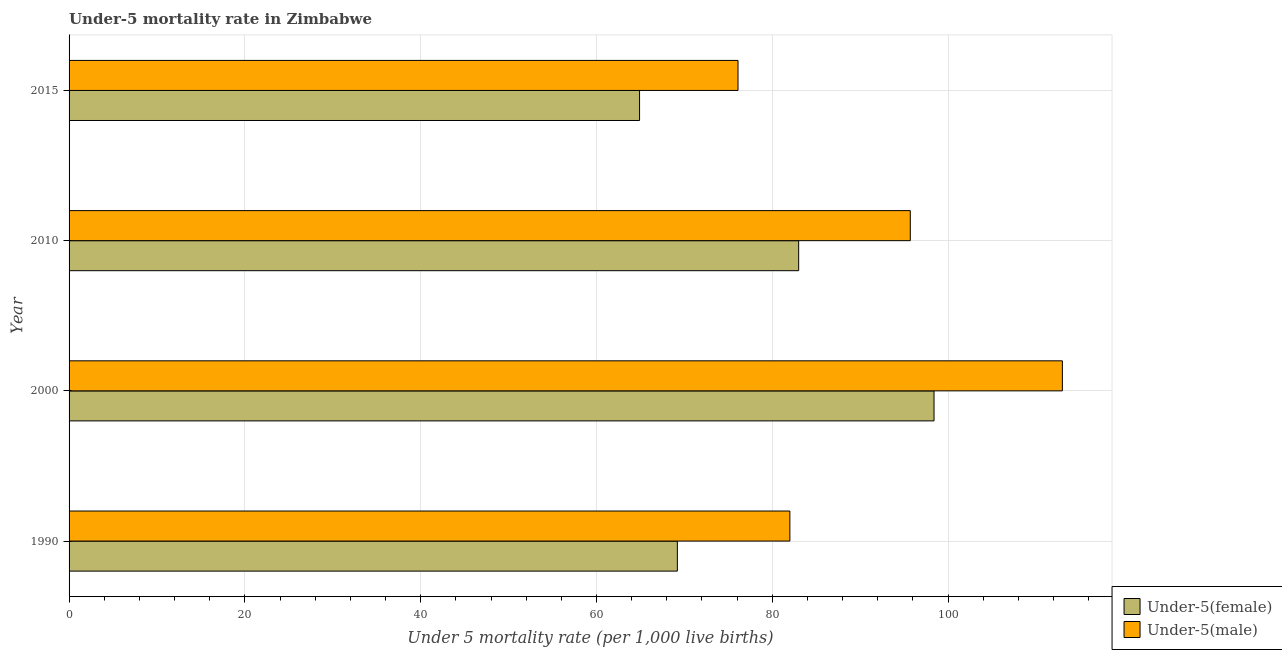Are the number of bars on each tick of the Y-axis equal?
Your answer should be compact. Yes. How many bars are there on the 1st tick from the bottom?
Your answer should be compact. 2. What is the label of the 3rd group of bars from the top?
Your answer should be compact. 2000. In how many cases, is the number of bars for a given year not equal to the number of legend labels?
Offer a terse response. 0. What is the under-5 female mortality rate in 2015?
Keep it short and to the point. 64.9. Across all years, what is the maximum under-5 male mortality rate?
Your answer should be compact. 113. Across all years, what is the minimum under-5 female mortality rate?
Your response must be concise. 64.9. In which year was the under-5 female mortality rate minimum?
Keep it short and to the point. 2015. What is the total under-5 male mortality rate in the graph?
Give a very brief answer. 366.8. What is the difference between the under-5 male mortality rate in 1990 and that in 2010?
Provide a short and direct response. -13.7. What is the difference between the under-5 male mortality rate in 2010 and the under-5 female mortality rate in 2000?
Your answer should be very brief. -2.7. What is the average under-5 female mortality rate per year?
Provide a short and direct response. 78.88. In the year 2015, what is the difference between the under-5 male mortality rate and under-5 female mortality rate?
Your response must be concise. 11.2. What is the ratio of the under-5 female mortality rate in 1990 to that in 2015?
Your answer should be compact. 1.07. What is the difference between the highest and the second highest under-5 male mortality rate?
Make the answer very short. 17.3. What is the difference between the highest and the lowest under-5 female mortality rate?
Your response must be concise. 33.5. In how many years, is the under-5 female mortality rate greater than the average under-5 female mortality rate taken over all years?
Offer a terse response. 2. What does the 2nd bar from the top in 2000 represents?
Ensure brevity in your answer.  Under-5(female). What does the 1st bar from the bottom in 2010 represents?
Offer a very short reply. Under-5(female). How many bars are there?
Your response must be concise. 8. Are the values on the major ticks of X-axis written in scientific E-notation?
Offer a very short reply. No. Does the graph contain any zero values?
Your response must be concise. No. What is the title of the graph?
Your answer should be compact. Under-5 mortality rate in Zimbabwe. Does "Working capital" appear as one of the legend labels in the graph?
Ensure brevity in your answer.  No. What is the label or title of the X-axis?
Your response must be concise. Under 5 mortality rate (per 1,0 live births). What is the Under 5 mortality rate (per 1,000 live births) of Under-5(female) in 1990?
Make the answer very short. 69.2. What is the Under 5 mortality rate (per 1,000 live births) of Under-5(female) in 2000?
Your response must be concise. 98.4. What is the Under 5 mortality rate (per 1,000 live births) in Under-5(male) in 2000?
Provide a short and direct response. 113. What is the Under 5 mortality rate (per 1,000 live births) of Under-5(female) in 2010?
Ensure brevity in your answer.  83. What is the Under 5 mortality rate (per 1,000 live births) in Under-5(male) in 2010?
Make the answer very short. 95.7. What is the Under 5 mortality rate (per 1,000 live births) in Under-5(female) in 2015?
Ensure brevity in your answer.  64.9. What is the Under 5 mortality rate (per 1,000 live births) in Under-5(male) in 2015?
Give a very brief answer. 76.1. Across all years, what is the maximum Under 5 mortality rate (per 1,000 live births) of Under-5(female)?
Your answer should be compact. 98.4. Across all years, what is the maximum Under 5 mortality rate (per 1,000 live births) of Under-5(male)?
Offer a very short reply. 113. Across all years, what is the minimum Under 5 mortality rate (per 1,000 live births) in Under-5(female)?
Your answer should be very brief. 64.9. Across all years, what is the minimum Under 5 mortality rate (per 1,000 live births) in Under-5(male)?
Your answer should be very brief. 76.1. What is the total Under 5 mortality rate (per 1,000 live births) of Under-5(female) in the graph?
Offer a very short reply. 315.5. What is the total Under 5 mortality rate (per 1,000 live births) in Under-5(male) in the graph?
Your answer should be very brief. 366.8. What is the difference between the Under 5 mortality rate (per 1,000 live births) of Under-5(female) in 1990 and that in 2000?
Provide a succinct answer. -29.2. What is the difference between the Under 5 mortality rate (per 1,000 live births) of Under-5(male) in 1990 and that in 2000?
Make the answer very short. -31. What is the difference between the Under 5 mortality rate (per 1,000 live births) of Under-5(female) in 1990 and that in 2010?
Provide a succinct answer. -13.8. What is the difference between the Under 5 mortality rate (per 1,000 live births) of Under-5(male) in 1990 and that in 2010?
Your answer should be very brief. -13.7. What is the difference between the Under 5 mortality rate (per 1,000 live births) of Under-5(male) in 2000 and that in 2010?
Keep it short and to the point. 17.3. What is the difference between the Under 5 mortality rate (per 1,000 live births) in Under-5(female) in 2000 and that in 2015?
Ensure brevity in your answer.  33.5. What is the difference between the Under 5 mortality rate (per 1,000 live births) of Under-5(male) in 2000 and that in 2015?
Ensure brevity in your answer.  36.9. What is the difference between the Under 5 mortality rate (per 1,000 live births) of Under-5(male) in 2010 and that in 2015?
Give a very brief answer. 19.6. What is the difference between the Under 5 mortality rate (per 1,000 live births) in Under-5(female) in 1990 and the Under 5 mortality rate (per 1,000 live births) in Under-5(male) in 2000?
Your response must be concise. -43.8. What is the difference between the Under 5 mortality rate (per 1,000 live births) of Under-5(female) in 1990 and the Under 5 mortality rate (per 1,000 live births) of Under-5(male) in 2010?
Offer a very short reply. -26.5. What is the difference between the Under 5 mortality rate (per 1,000 live births) of Under-5(female) in 1990 and the Under 5 mortality rate (per 1,000 live births) of Under-5(male) in 2015?
Keep it short and to the point. -6.9. What is the difference between the Under 5 mortality rate (per 1,000 live births) of Under-5(female) in 2000 and the Under 5 mortality rate (per 1,000 live births) of Under-5(male) in 2015?
Your answer should be compact. 22.3. What is the difference between the Under 5 mortality rate (per 1,000 live births) in Under-5(female) in 2010 and the Under 5 mortality rate (per 1,000 live births) in Under-5(male) in 2015?
Your answer should be compact. 6.9. What is the average Under 5 mortality rate (per 1,000 live births) of Under-5(female) per year?
Ensure brevity in your answer.  78.88. What is the average Under 5 mortality rate (per 1,000 live births) in Under-5(male) per year?
Offer a terse response. 91.7. In the year 2000, what is the difference between the Under 5 mortality rate (per 1,000 live births) in Under-5(female) and Under 5 mortality rate (per 1,000 live births) in Under-5(male)?
Offer a terse response. -14.6. In the year 2010, what is the difference between the Under 5 mortality rate (per 1,000 live births) in Under-5(female) and Under 5 mortality rate (per 1,000 live births) in Under-5(male)?
Offer a very short reply. -12.7. In the year 2015, what is the difference between the Under 5 mortality rate (per 1,000 live births) of Under-5(female) and Under 5 mortality rate (per 1,000 live births) of Under-5(male)?
Your response must be concise. -11.2. What is the ratio of the Under 5 mortality rate (per 1,000 live births) in Under-5(female) in 1990 to that in 2000?
Ensure brevity in your answer.  0.7. What is the ratio of the Under 5 mortality rate (per 1,000 live births) of Under-5(male) in 1990 to that in 2000?
Your answer should be very brief. 0.73. What is the ratio of the Under 5 mortality rate (per 1,000 live births) of Under-5(female) in 1990 to that in 2010?
Provide a succinct answer. 0.83. What is the ratio of the Under 5 mortality rate (per 1,000 live births) of Under-5(male) in 1990 to that in 2010?
Ensure brevity in your answer.  0.86. What is the ratio of the Under 5 mortality rate (per 1,000 live births) of Under-5(female) in 1990 to that in 2015?
Your response must be concise. 1.07. What is the ratio of the Under 5 mortality rate (per 1,000 live births) in Under-5(male) in 1990 to that in 2015?
Offer a very short reply. 1.08. What is the ratio of the Under 5 mortality rate (per 1,000 live births) of Under-5(female) in 2000 to that in 2010?
Ensure brevity in your answer.  1.19. What is the ratio of the Under 5 mortality rate (per 1,000 live births) in Under-5(male) in 2000 to that in 2010?
Your response must be concise. 1.18. What is the ratio of the Under 5 mortality rate (per 1,000 live births) of Under-5(female) in 2000 to that in 2015?
Ensure brevity in your answer.  1.52. What is the ratio of the Under 5 mortality rate (per 1,000 live births) of Under-5(male) in 2000 to that in 2015?
Provide a succinct answer. 1.48. What is the ratio of the Under 5 mortality rate (per 1,000 live births) of Under-5(female) in 2010 to that in 2015?
Offer a terse response. 1.28. What is the ratio of the Under 5 mortality rate (per 1,000 live births) of Under-5(male) in 2010 to that in 2015?
Keep it short and to the point. 1.26. What is the difference between the highest and the second highest Under 5 mortality rate (per 1,000 live births) in Under-5(female)?
Give a very brief answer. 15.4. What is the difference between the highest and the lowest Under 5 mortality rate (per 1,000 live births) of Under-5(female)?
Offer a very short reply. 33.5. What is the difference between the highest and the lowest Under 5 mortality rate (per 1,000 live births) in Under-5(male)?
Offer a very short reply. 36.9. 